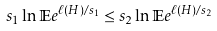<formula> <loc_0><loc_0><loc_500><loc_500>s _ { 1 } \ln \mathbb { E } e ^ { \ell ( H ) / s _ { 1 } } \leq s _ { 2 } \ln \mathbb { E } e ^ { \ell ( H ) / s _ { 2 } }</formula> 